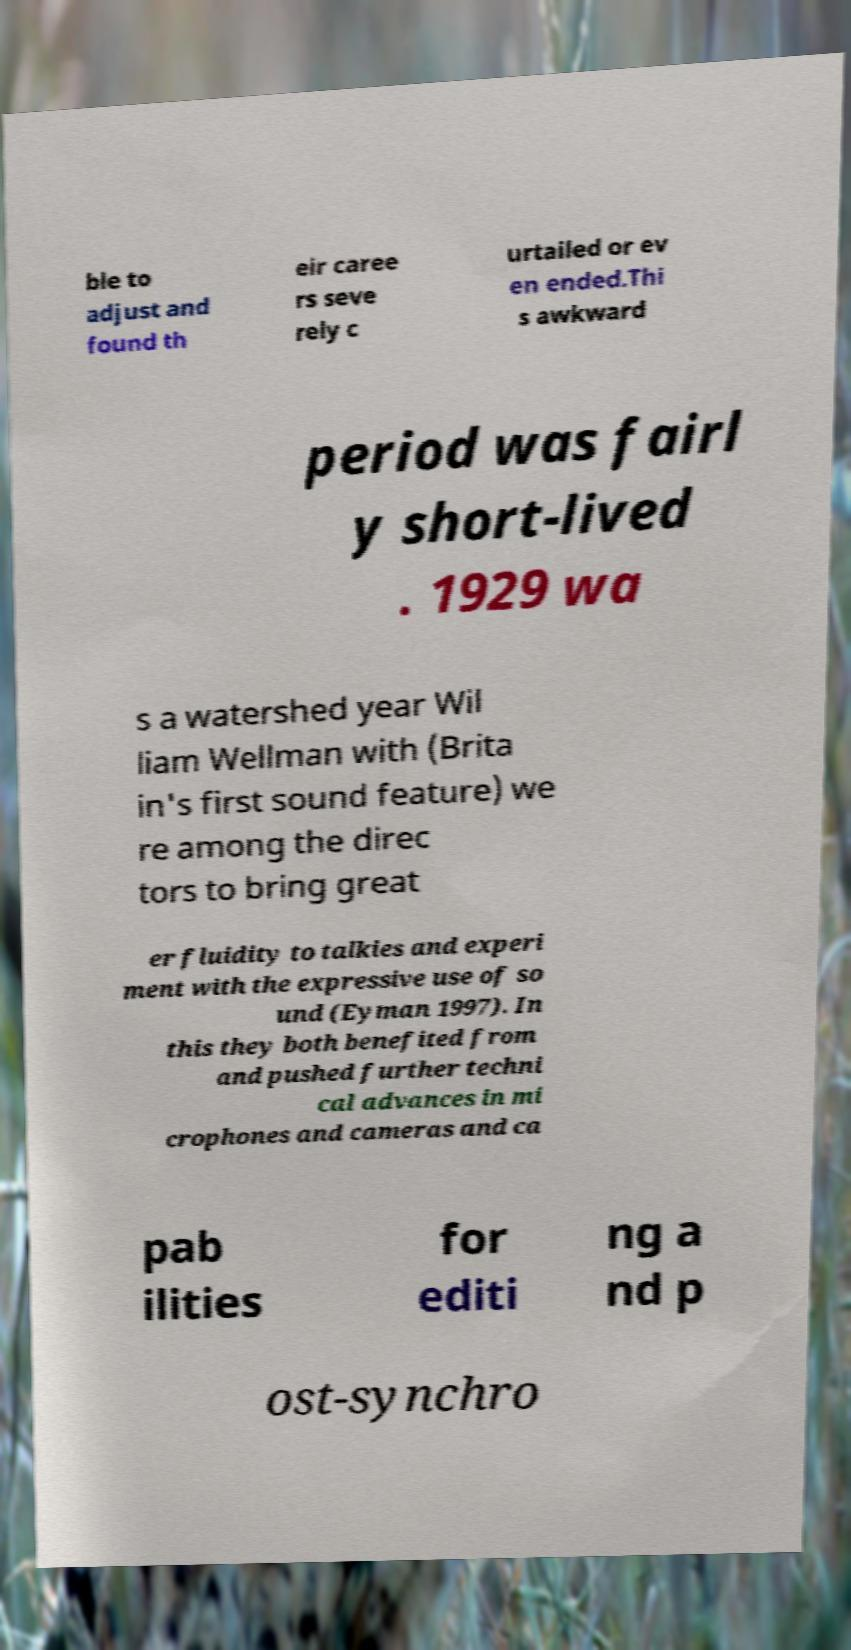Please read and relay the text visible in this image. What does it say? ble to adjust and found th eir caree rs seve rely c urtailed or ev en ended.Thi s awkward period was fairl y short-lived . 1929 wa s a watershed year Wil liam Wellman with (Brita in's first sound feature) we re among the direc tors to bring great er fluidity to talkies and experi ment with the expressive use of so und (Eyman 1997). In this they both benefited from and pushed further techni cal advances in mi crophones and cameras and ca pab ilities for editi ng a nd p ost-synchro 